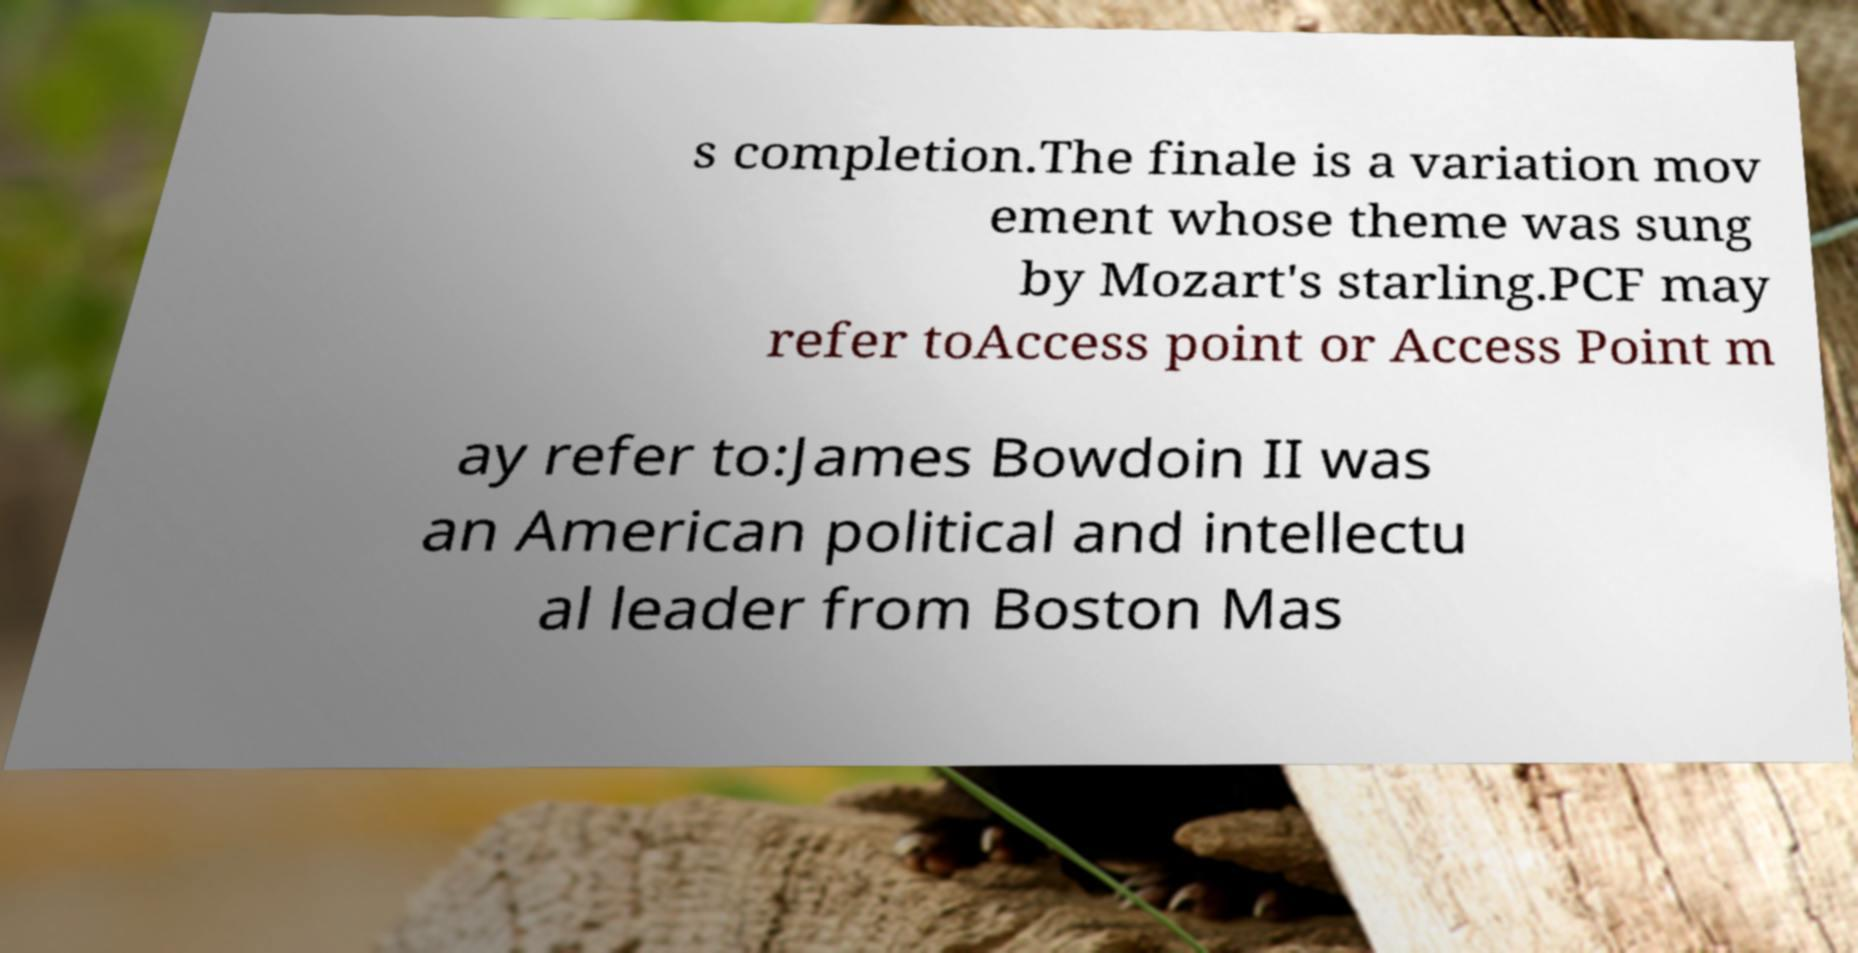Could you assist in decoding the text presented in this image and type it out clearly? s completion.The finale is a variation mov ement whose theme was sung by Mozart's starling.PCF may refer toAccess point or Access Point m ay refer to:James Bowdoin II was an American political and intellectu al leader from Boston Mas 